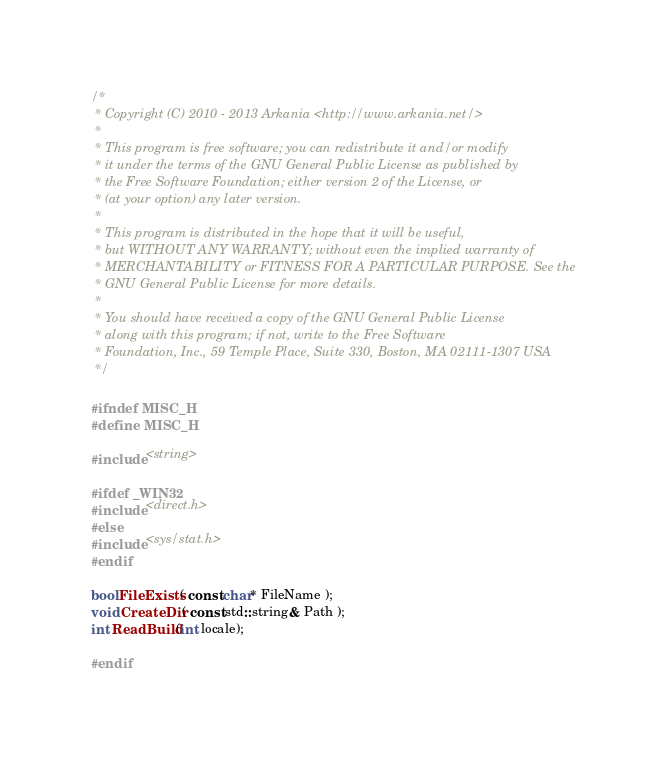<code> <loc_0><loc_0><loc_500><loc_500><_C_>/*
 * Copyright (C) 2010 - 2013 Arkania <http://www.arkania.net/>
 *
 * This program is free software; you can redistribute it and/or modify
 * it under the terms of the GNU General Public License as published by
 * the Free Software Foundation; either version 2 of the License, or
 * (at your option) any later version.
 *
 * This program is distributed in the hope that it will be useful,
 * but WITHOUT ANY WARRANTY; without even the implied warranty of
 * MERCHANTABILITY or FITNESS FOR A PARTICULAR PURPOSE. See the
 * GNU General Public License for more details.
 *
 * You should have received a copy of the GNU General Public License
 * along with this program; if not, write to the Free Software
 * Foundation, Inc., 59 Temple Place, Suite 330, Boston, MA 02111-1307 USA
 */

#ifndef MISC_H
#define MISC_H

#include <string>

#ifdef _WIN32
#include <direct.h>
#else
#include <sys/stat.h>
#endif

bool FileExists( const char* FileName );
void CreateDir( const std::string& Path );
int ReadBuild(int locale);

#endif</code> 